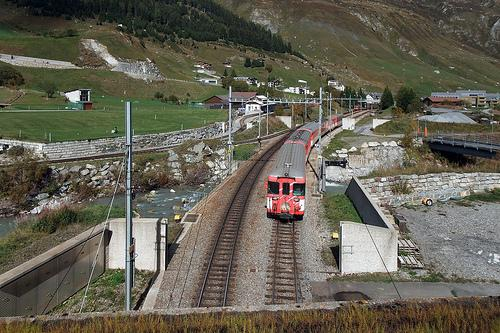Question: what is sitting on the tracks?
Choices:
A. A boy.
B. Train.
C. A girl.
D. A car.
Answer with the letter. Answer: B Question: what is the form of transportation in the picture?
Choices:
A. A car.
B. Train.
C. A truck.
D. A boat.
Answer with the letter. Answer: B Question: where is the train sitting?
Choices:
A. On the ground.
B. In the air.
C. On the tracks.
D. On a boat.
Answer with the letter. Answer: C Question: what is in the far background?
Choices:
A. Trees.
B. Mountains.
C. Clouds.
D. A rainbow.
Answer with the letter. Answer: B 